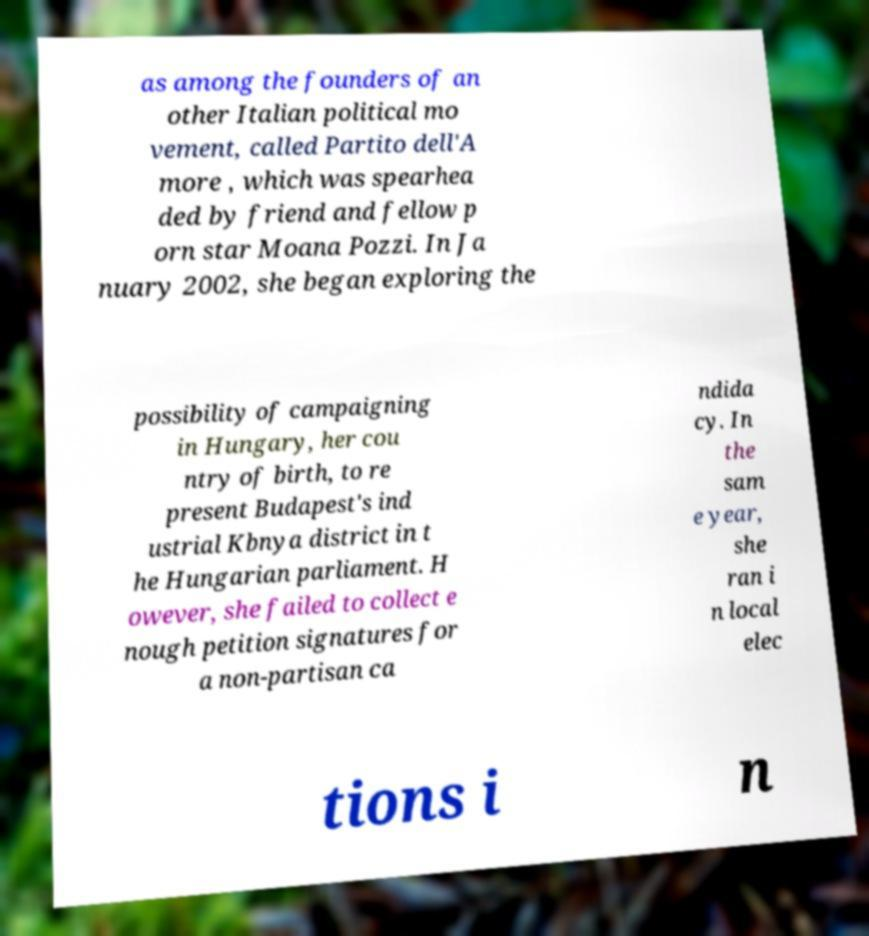Can you read and provide the text displayed in the image?This photo seems to have some interesting text. Can you extract and type it out for me? as among the founders of an other Italian political mo vement, called Partito dell'A more , which was spearhea ded by friend and fellow p orn star Moana Pozzi. In Ja nuary 2002, she began exploring the possibility of campaigning in Hungary, her cou ntry of birth, to re present Budapest's ind ustrial Kbnya district in t he Hungarian parliament. H owever, she failed to collect e nough petition signatures for a non-partisan ca ndida cy. In the sam e year, she ran i n local elec tions i n 